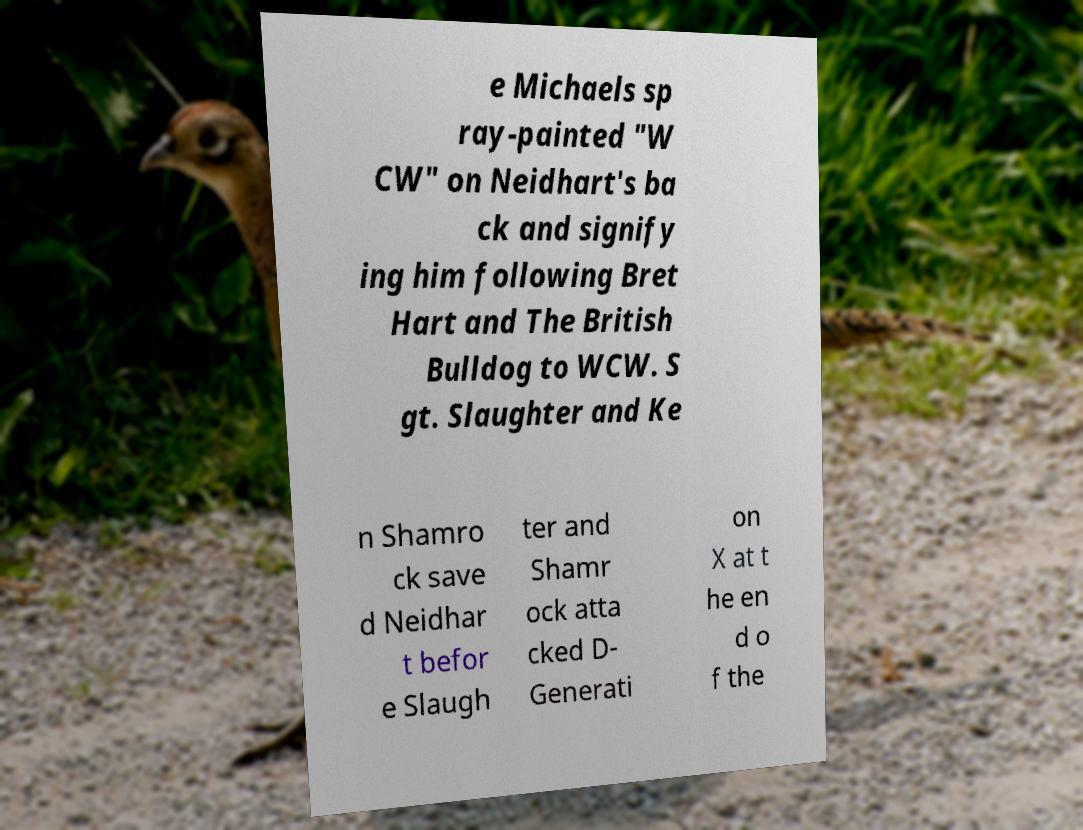Can you accurately transcribe the text from the provided image for me? e Michaels sp ray-painted "W CW" on Neidhart's ba ck and signify ing him following Bret Hart and The British Bulldog to WCW. S gt. Slaughter and Ke n Shamro ck save d Neidhar t befor e Slaugh ter and Shamr ock atta cked D- Generati on X at t he en d o f the 